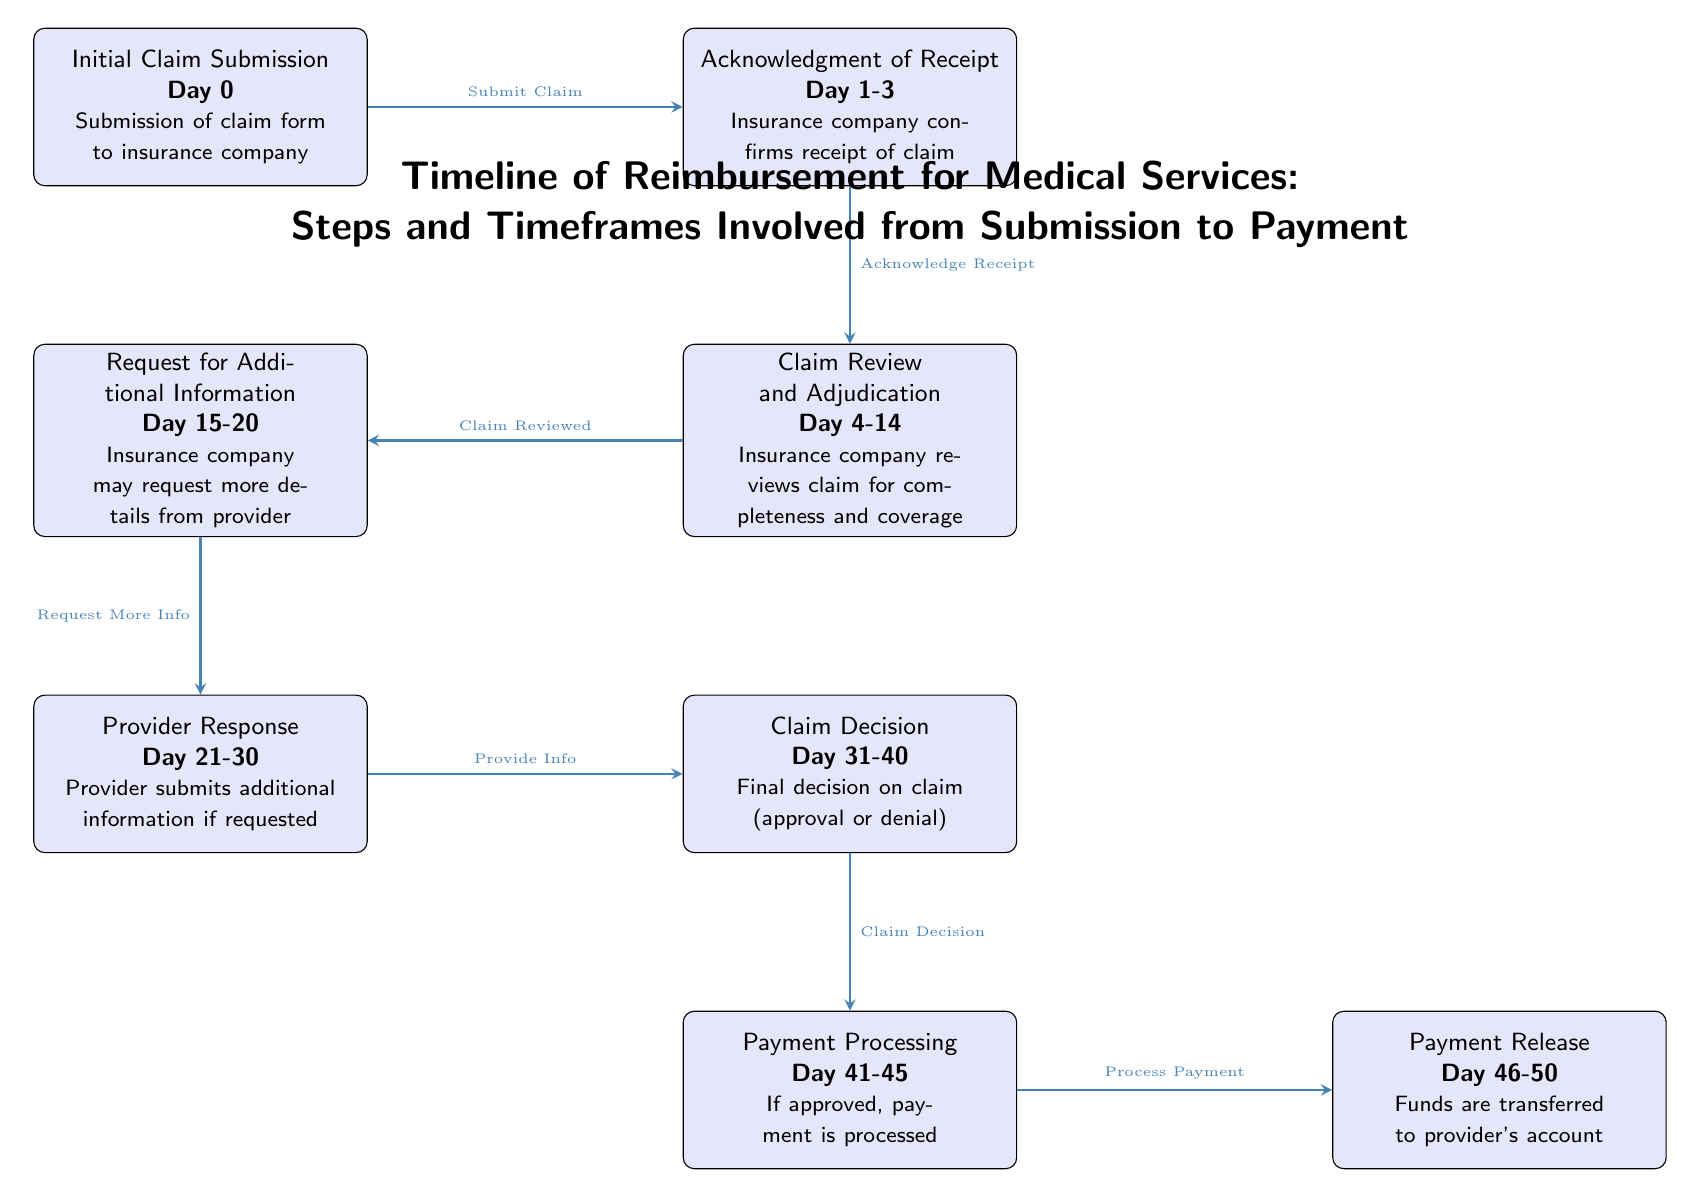What is the timeframe for Initial Claim Submission? The diagram indicates that Initial Claim Submission occurs on Day 0.
Answer: Day 0 How many days are allocated for Claim Review and Adjudication? According to the diagram, the Claim Review and Adjudication step takes from Day 4 to Day 14, which is a total of 10 days.
Answer: 10 days What action occurs after the Acknowledgment of Receipt? Following Acknowledgment of Receipt, the diagram shows the next action is Claim Review and Adjudication.
Answer: Claim Review and Adjudication During which days might the Insurance company request additional information? The diagram specifies that the Request for Additional Information happens between Day 15 and Day 20.
Answer: Day 15-20 What is the final action in the timeline of reimbursement? The last action listed in the diagram is Payment Release.
Answer: Payment Release What is the duration between Claim Decision and Payment Release? The diagram indicates that Claim Decision occurs on Day 31-40, and Payment Release occurs on Day 46-50. This represents a duration of 6 to 20 days, depending on the specific day of Payment Release.
Answer: 6 to 20 days Which step comes directly after Provider Response? The workflow shows that after Provider Response, the next step is Claim Decision.
Answer: Claim Decision How many total steps are there in the reimbursement timeline? By counting the nodes in the diagram, there are a total of 7 steps involved from submission to payment.
Answer: 7 steps What is the first step in the reimbursement process? The diagram indicates that the first step in the reimbursement process is Initial Claim Submission.
Answer: Initial Claim Submission 